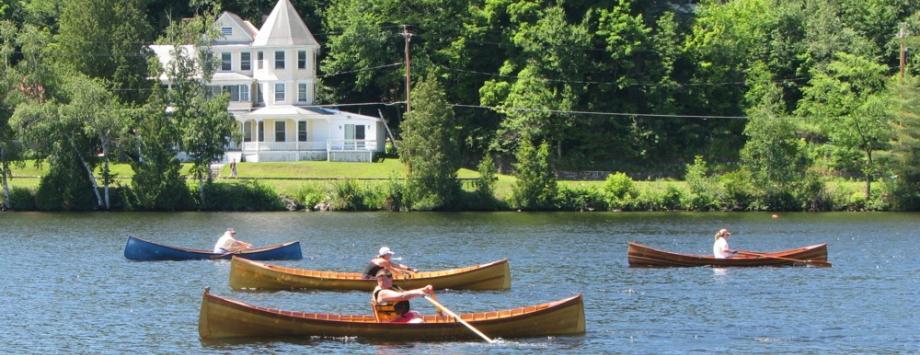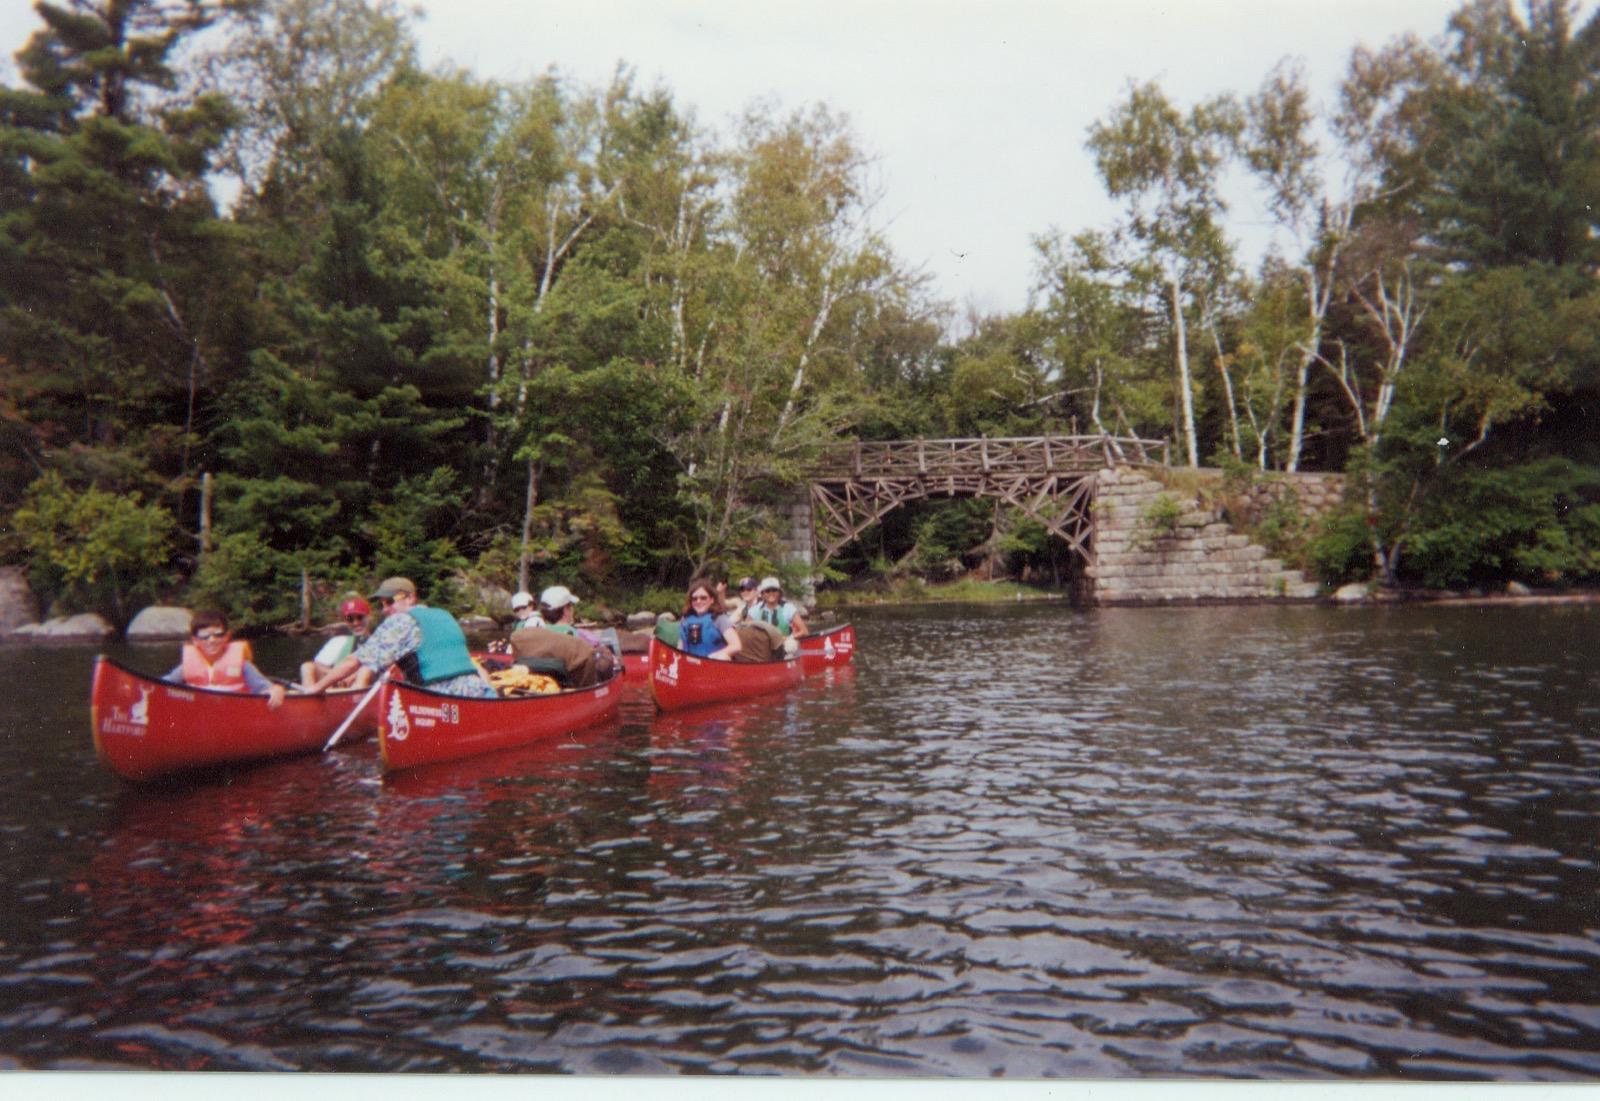The first image is the image on the left, the second image is the image on the right. For the images shown, is this caption "One image contains at least one red canoe on water, and the other contains at least one beige canoe." true? Answer yes or no. Yes. The first image is the image on the left, the second image is the image on the right. Assess this claim about the two images: "There are no more than 4 canoeists.". Correct or not? Answer yes or no. No. 